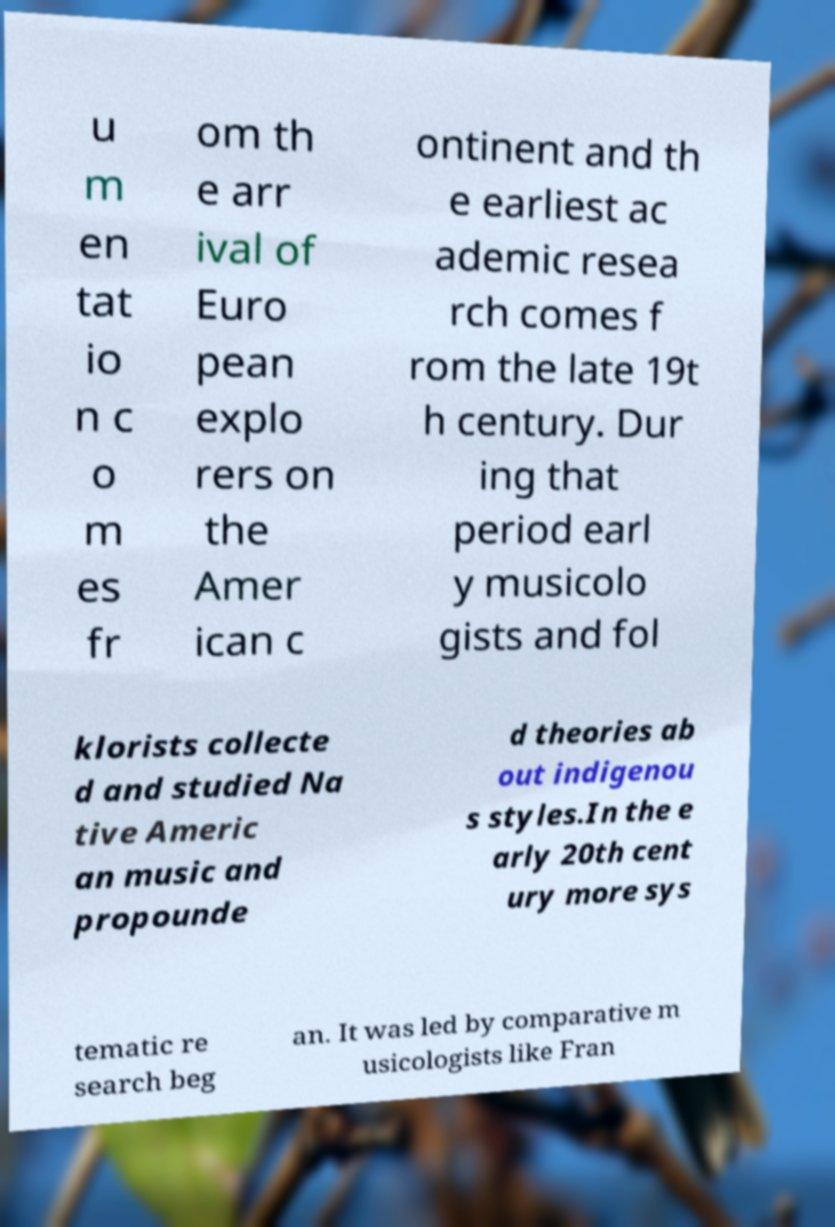I need the written content from this picture converted into text. Can you do that? u m en tat io n c o m es fr om th e arr ival of Euro pean explo rers on the Amer ican c ontinent and th e earliest ac ademic resea rch comes f rom the late 19t h century. Dur ing that period earl y musicolo gists and fol klorists collecte d and studied Na tive Americ an music and propounde d theories ab out indigenou s styles.In the e arly 20th cent ury more sys tematic re search beg an. It was led by comparative m usicologists like Fran 